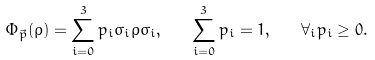Convert formula to latex. <formula><loc_0><loc_0><loc_500><loc_500>\Phi _ { \vec { p } } ( \rho ) = \sum _ { i = 0 } ^ { 3 } p _ { i } \sigma _ { i } \rho \sigma _ { i } , \quad \sum _ { i = 0 } ^ { 3 } p _ { i } = 1 , \quad \forall _ { i } p _ { i } \geq 0 .</formula> 